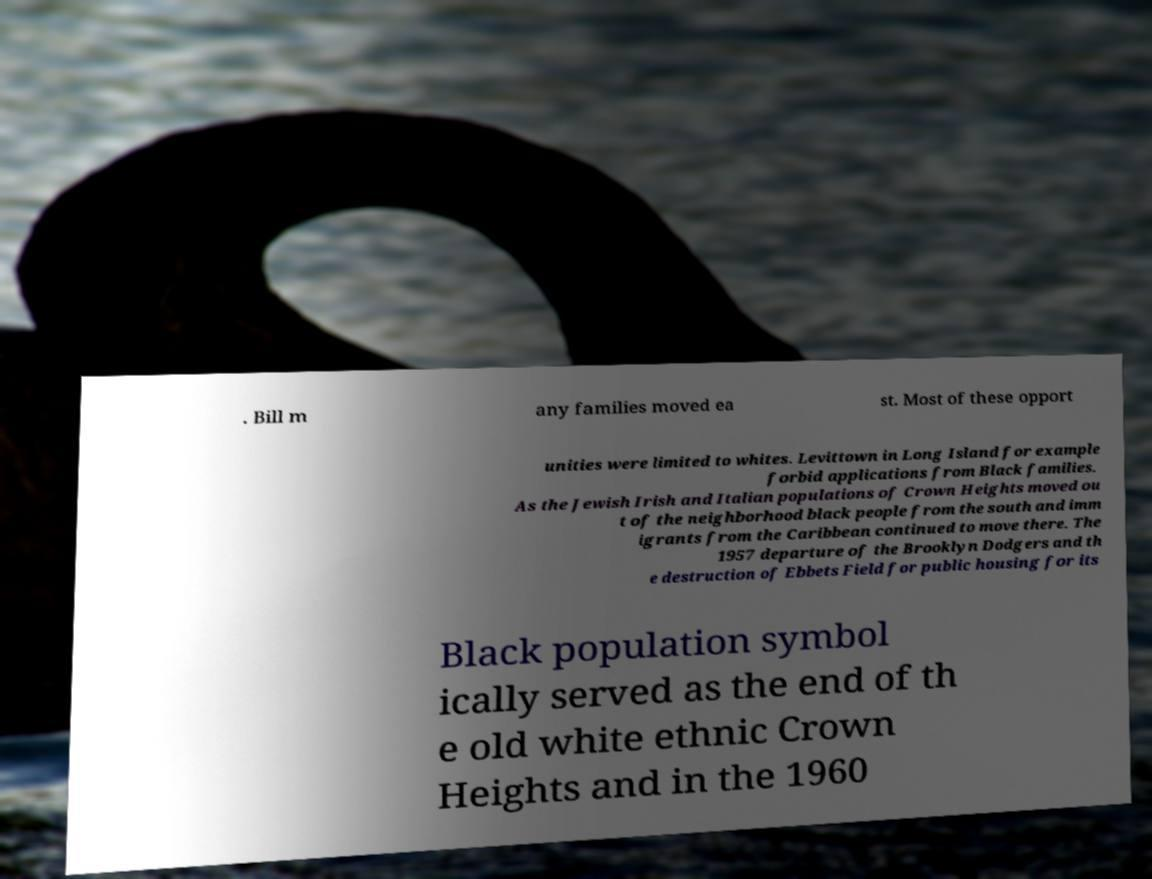There's text embedded in this image that I need extracted. Can you transcribe it verbatim? . Bill m any families moved ea st. Most of these opport unities were limited to whites. Levittown in Long Island for example forbid applications from Black families. As the Jewish Irish and Italian populations of Crown Heights moved ou t of the neighborhood black people from the south and imm igrants from the Caribbean continued to move there. The 1957 departure of the Brooklyn Dodgers and th e destruction of Ebbets Field for public housing for its Black population symbol ically served as the end of th e old white ethnic Crown Heights and in the 1960 